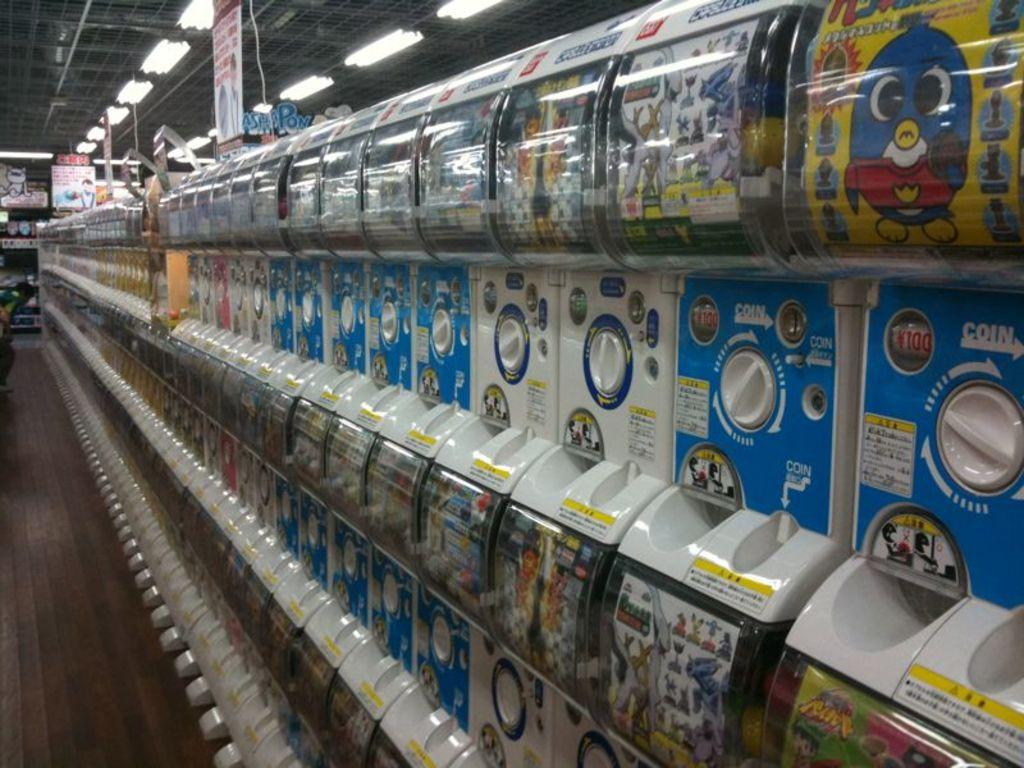<image>
Offer a succinct explanation of the picture presented. A row of vending machines that say coin in white 